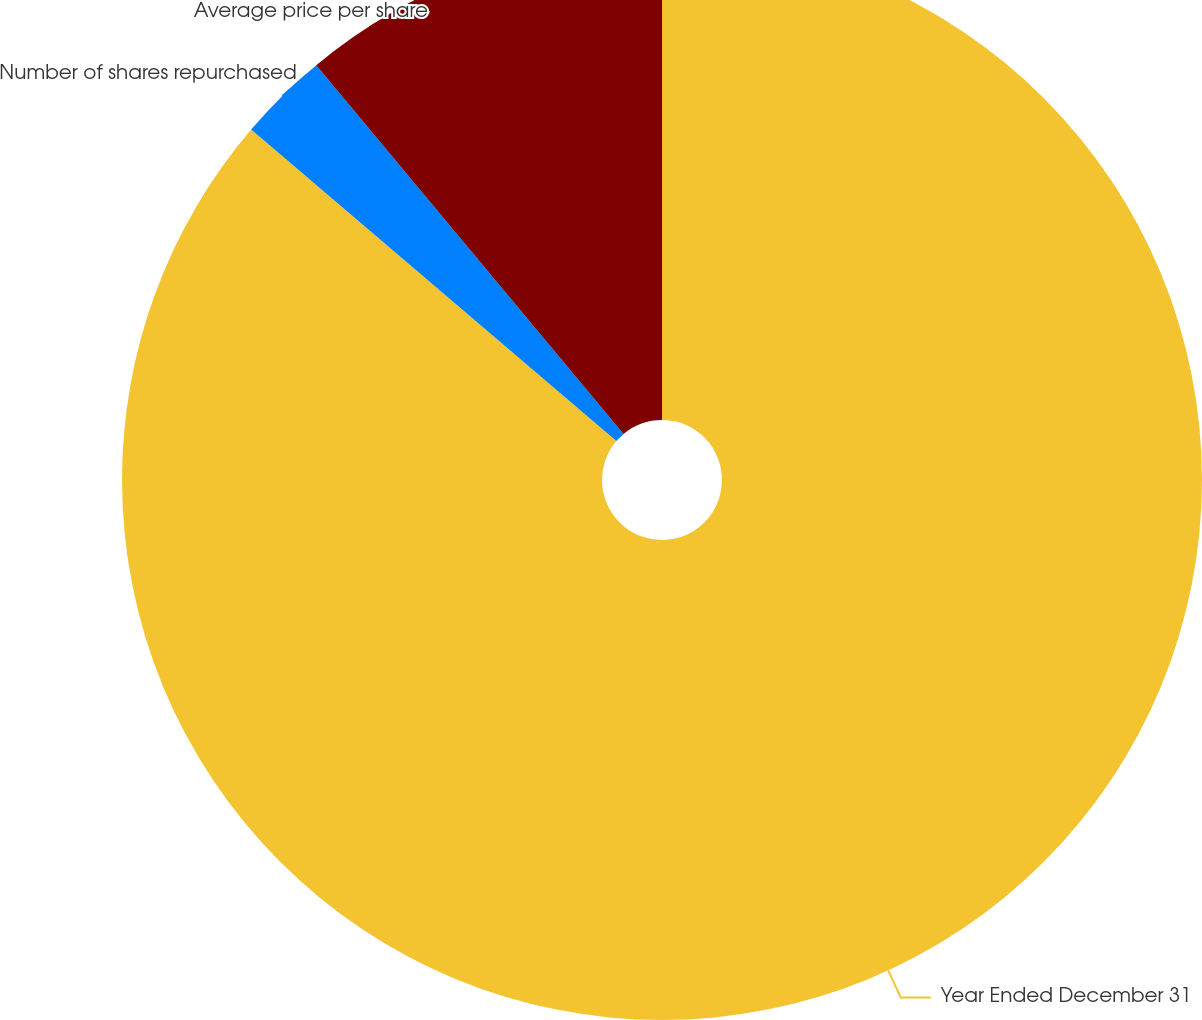Convert chart to OTSL. <chart><loc_0><loc_0><loc_500><loc_500><pie_chart><fcel>Year Ended December 31<fcel>Number of shares repurchased<fcel>Average price per share<nl><fcel>86.24%<fcel>2.7%<fcel>11.06%<nl></chart> 